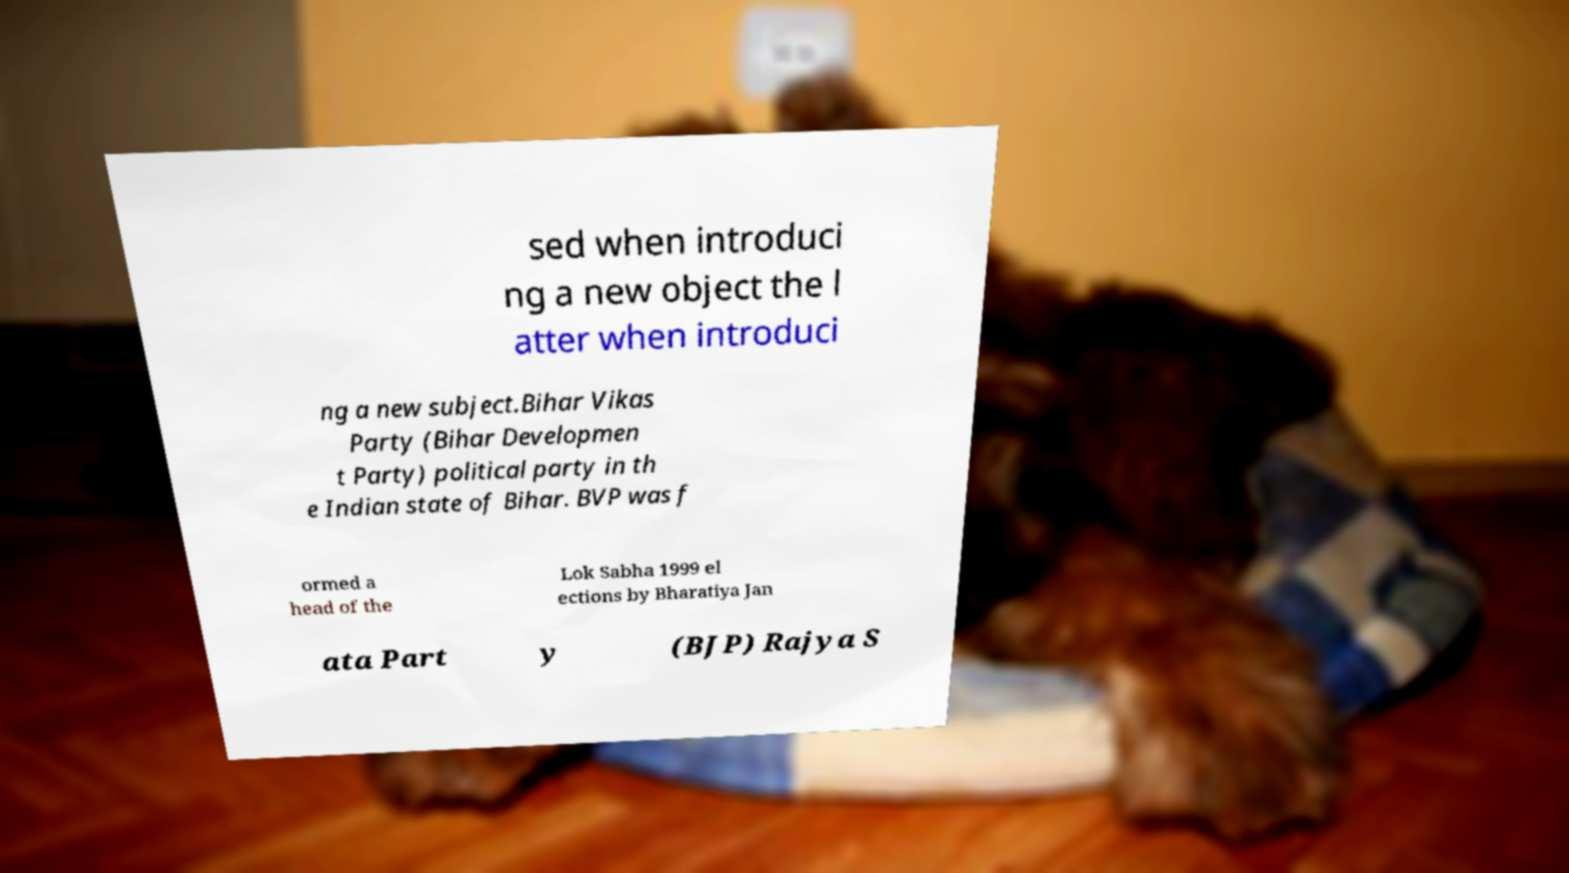Please read and relay the text visible in this image. What does it say? sed when introduci ng a new object the l atter when introduci ng a new subject.Bihar Vikas Party (Bihar Developmen t Party) political party in th e Indian state of Bihar. BVP was f ormed a head of the Lok Sabha 1999 el ections by Bharatiya Jan ata Part y (BJP) Rajya S 